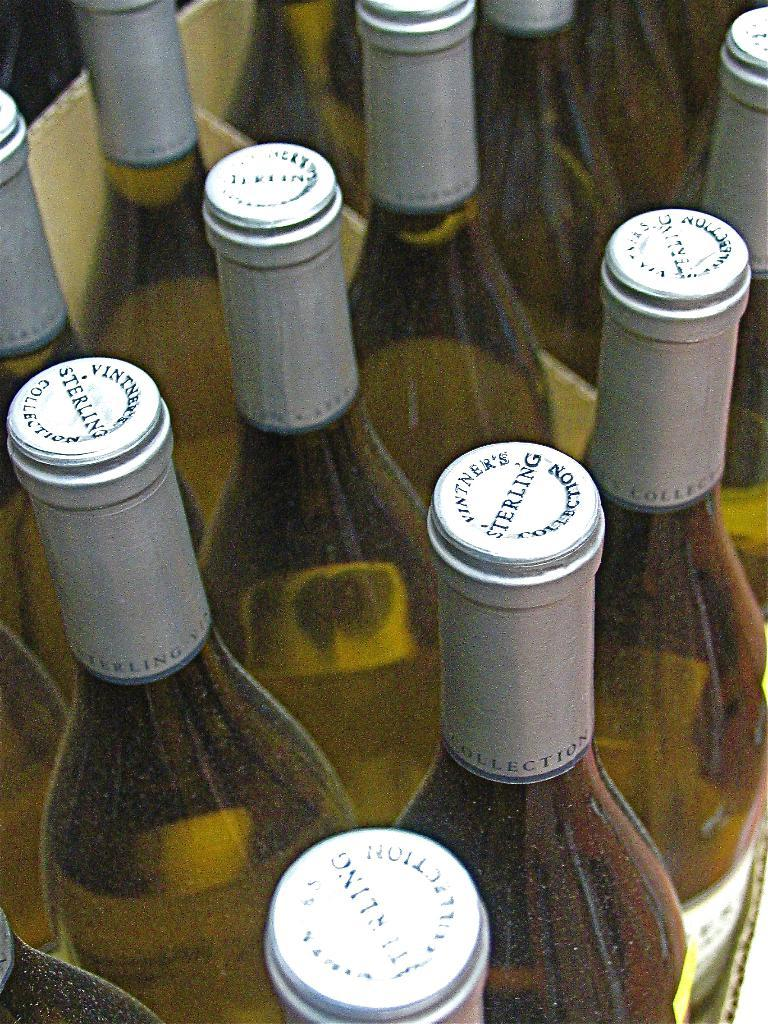Provide a one-sentence caption for the provided image. bottles of white wine from Vintner's Sterling collection. 